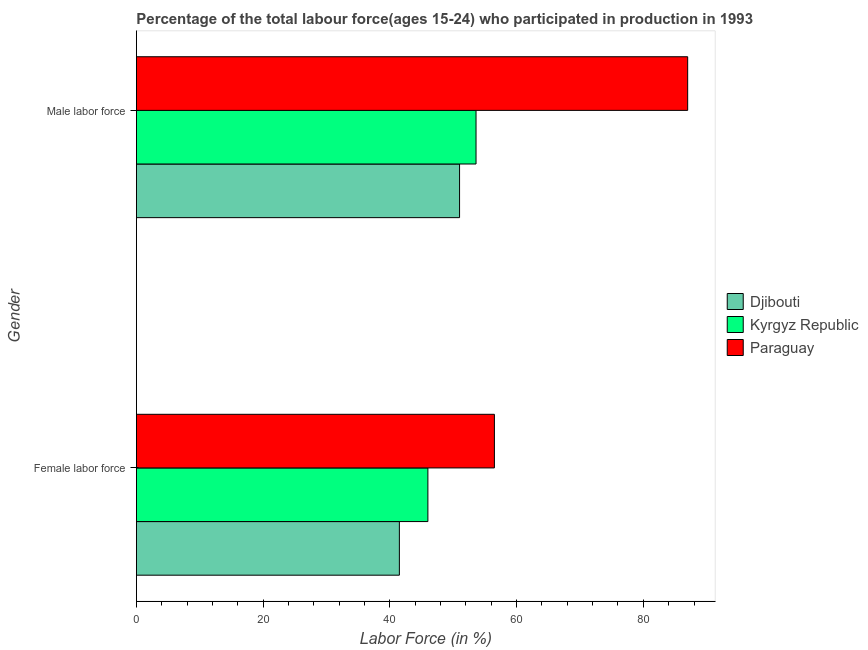How many different coloured bars are there?
Ensure brevity in your answer.  3. Are the number of bars per tick equal to the number of legend labels?
Offer a terse response. Yes. How many bars are there on the 1st tick from the top?
Make the answer very short. 3. How many bars are there on the 2nd tick from the bottom?
Give a very brief answer. 3. What is the label of the 2nd group of bars from the top?
Offer a terse response. Female labor force. What is the percentage of female labor force in Kyrgyz Republic?
Make the answer very short. 46. Across all countries, what is the maximum percentage of female labor force?
Your answer should be very brief. 56.5. Across all countries, what is the minimum percentage of female labor force?
Ensure brevity in your answer.  41.5. In which country was the percentage of male labour force maximum?
Keep it short and to the point. Paraguay. In which country was the percentage of female labor force minimum?
Your response must be concise. Djibouti. What is the total percentage of female labor force in the graph?
Make the answer very short. 144. What is the difference between the percentage of male labour force in Paraguay and that in Djibouti?
Provide a succinct answer. 36. What is the difference between the percentage of female labor force in Djibouti and the percentage of male labour force in Paraguay?
Make the answer very short. -45.5. What is the average percentage of female labor force per country?
Ensure brevity in your answer.  48. What is the difference between the percentage of female labor force and percentage of male labour force in Kyrgyz Republic?
Offer a very short reply. -7.6. In how many countries, is the percentage of male labour force greater than 84 %?
Make the answer very short. 1. What is the ratio of the percentage of female labor force in Kyrgyz Republic to that in Paraguay?
Offer a very short reply. 0.81. In how many countries, is the percentage of female labor force greater than the average percentage of female labor force taken over all countries?
Offer a very short reply. 1. What does the 3rd bar from the top in Female labor force represents?
Provide a succinct answer. Djibouti. What does the 2nd bar from the bottom in Female labor force represents?
Provide a succinct answer. Kyrgyz Republic. How many countries are there in the graph?
Give a very brief answer. 3. What is the difference between two consecutive major ticks on the X-axis?
Ensure brevity in your answer.  20. Does the graph contain any zero values?
Offer a very short reply. No. How many legend labels are there?
Give a very brief answer. 3. How are the legend labels stacked?
Your answer should be very brief. Vertical. What is the title of the graph?
Offer a terse response. Percentage of the total labour force(ages 15-24) who participated in production in 1993. Does "Bahrain" appear as one of the legend labels in the graph?
Make the answer very short. No. What is the label or title of the X-axis?
Your answer should be compact. Labor Force (in %). What is the label or title of the Y-axis?
Your answer should be very brief. Gender. What is the Labor Force (in %) in Djibouti in Female labor force?
Your answer should be compact. 41.5. What is the Labor Force (in %) in Paraguay in Female labor force?
Offer a terse response. 56.5. What is the Labor Force (in %) in Kyrgyz Republic in Male labor force?
Provide a short and direct response. 53.6. What is the Labor Force (in %) in Paraguay in Male labor force?
Provide a short and direct response. 87. Across all Gender, what is the maximum Labor Force (in %) in Kyrgyz Republic?
Make the answer very short. 53.6. Across all Gender, what is the maximum Labor Force (in %) in Paraguay?
Keep it short and to the point. 87. Across all Gender, what is the minimum Labor Force (in %) of Djibouti?
Ensure brevity in your answer.  41.5. Across all Gender, what is the minimum Labor Force (in %) in Paraguay?
Your response must be concise. 56.5. What is the total Labor Force (in %) of Djibouti in the graph?
Offer a very short reply. 92.5. What is the total Labor Force (in %) in Kyrgyz Republic in the graph?
Keep it short and to the point. 99.6. What is the total Labor Force (in %) of Paraguay in the graph?
Give a very brief answer. 143.5. What is the difference between the Labor Force (in %) in Kyrgyz Republic in Female labor force and that in Male labor force?
Give a very brief answer. -7.6. What is the difference between the Labor Force (in %) of Paraguay in Female labor force and that in Male labor force?
Provide a short and direct response. -30.5. What is the difference between the Labor Force (in %) in Djibouti in Female labor force and the Labor Force (in %) in Kyrgyz Republic in Male labor force?
Ensure brevity in your answer.  -12.1. What is the difference between the Labor Force (in %) of Djibouti in Female labor force and the Labor Force (in %) of Paraguay in Male labor force?
Your answer should be compact. -45.5. What is the difference between the Labor Force (in %) in Kyrgyz Republic in Female labor force and the Labor Force (in %) in Paraguay in Male labor force?
Keep it short and to the point. -41. What is the average Labor Force (in %) of Djibouti per Gender?
Offer a terse response. 46.25. What is the average Labor Force (in %) in Kyrgyz Republic per Gender?
Your answer should be very brief. 49.8. What is the average Labor Force (in %) in Paraguay per Gender?
Your answer should be very brief. 71.75. What is the difference between the Labor Force (in %) of Djibouti and Labor Force (in %) of Paraguay in Female labor force?
Provide a succinct answer. -15. What is the difference between the Labor Force (in %) of Djibouti and Labor Force (in %) of Kyrgyz Republic in Male labor force?
Provide a succinct answer. -2.6. What is the difference between the Labor Force (in %) of Djibouti and Labor Force (in %) of Paraguay in Male labor force?
Provide a short and direct response. -36. What is the difference between the Labor Force (in %) in Kyrgyz Republic and Labor Force (in %) in Paraguay in Male labor force?
Provide a short and direct response. -33.4. What is the ratio of the Labor Force (in %) in Djibouti in Female labor force to that in Male labor force?
Offer a terse response. 0.81. What is the ratio of the Labor Force (in %) of Kyrgyz Republic in Female labor force to that in Male labor force?
Offer a terse response. 0.86. What is the ratio of the Labor Force (in %) in Paraguay in Female labor force to that in Male labor force?
Provide a succinct answer. 0.65. What is the difference between the highest and the second highest Labor Force (in %) of Kyrgyz Republic?
Your answer should be compact. 7.6. What is the difference between the highest and the second highest Labor Force (in %) in Paraguay?
Your answer should be compact. 30.5. What is the difference between the highest and the lowest Labor Force (in %) of Djibouti?
Your answer should be compact. 9.5. What is the difference between the highest and the lowest Labor Force (in %) of Kyrgyz Republic?
Offer a very short reply. 7.6. What is the difference between the highest and the lowest Labor Force (in %) in Paraguay?
Offer a terse response. 30.5. 